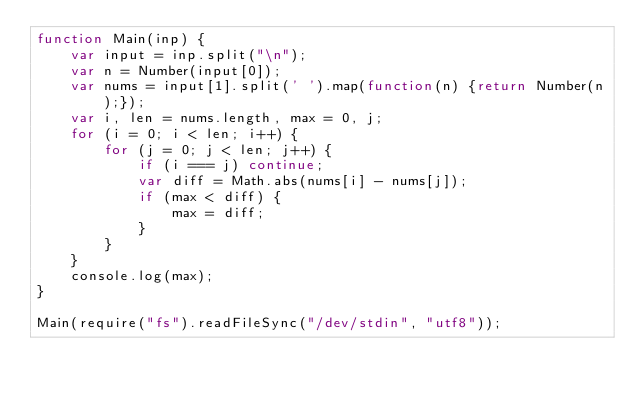Convert code to text. <code><loc_0><loc_0><loc_500><loc_500><_JavaScript_>function Main(inp) {
    var input = inp.split("\n");
    var n = Number(input[0]);
    var nums = input[1].split(' ').map(function(n) {return Number(n);});
    var i, len = nums.length, max = 0, j;
    for (i = 0; i < len; i++) {
        for (j = 0; j < len; j++) {
            if (i === j) continue;
            var diff = Math.abs(nums[i] - nums[j]);
            if (max < diff) {
                max = diff;
            }
        }
    }
    console.log(max);
}

Main(require("fs").readFileSync("/dev/stdin", "utf8"));</code> 